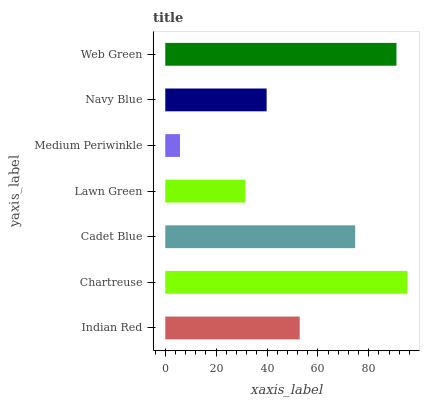Is Medium Periwinkle the minimum?
Answer yes or no. Yes. Is Chartreuse the maximum?
Answer yes or no. Yes. Is Cadet Blue the minimum?
Answer yes or no. No. Is Cadet Blue the maximum?
Answer yes or no. No. Is Chartreuse greater than Cadet Blue?
Answer yes or no. Yes. Is Cadet Blue less than Chartreuse?
Answer yes or no. Yes. Is Cadet Blue greater than Chartreuse?
Answer yes or no. No. Is Chartreuse less than Cadet Blue?
Answer yes or no. No. Is Indian Red the high median?
Answer yes or no. Yes. Is Indian Red the low median?
Answer yes or no. Yes. Is Cadet Blue the high median?
Answer yes or no. No. Is Chartreuse the low median?
Answer yes or no. No. 